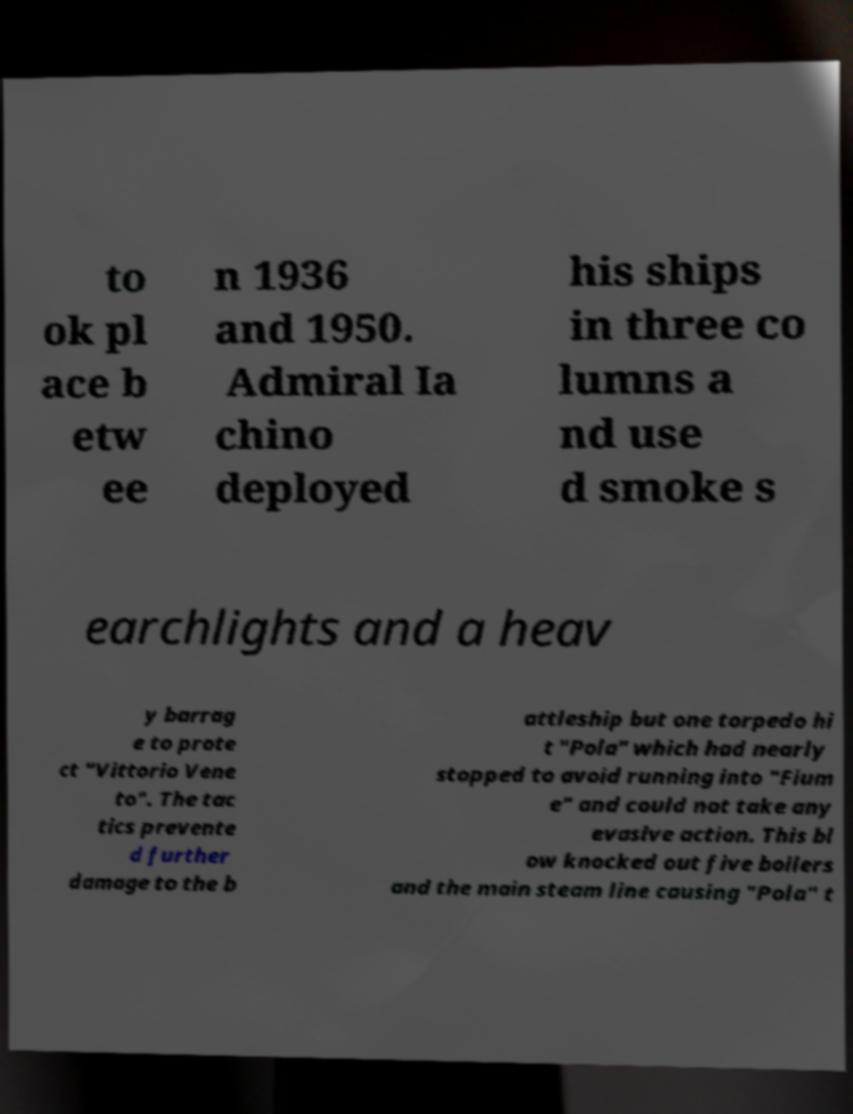What messages or text are displayed in this image? I need them in a readable, typed format. to ok pl ace b etw ee n 1936 and 1950. Admiral Ia chino deployed his ships in three co lumns a nd use d smoke s earchlights and a heav y barrag e to prote ct "Vittorio Vene to". The tac tics prevente d further damage to the b attleship but one torpedo hi t "Pola" which had nearly stopped to avoid running into "Fium e" and could not take any evasive action. This bl ow knocked out five boilers and the main steam line causing "Pola" t 